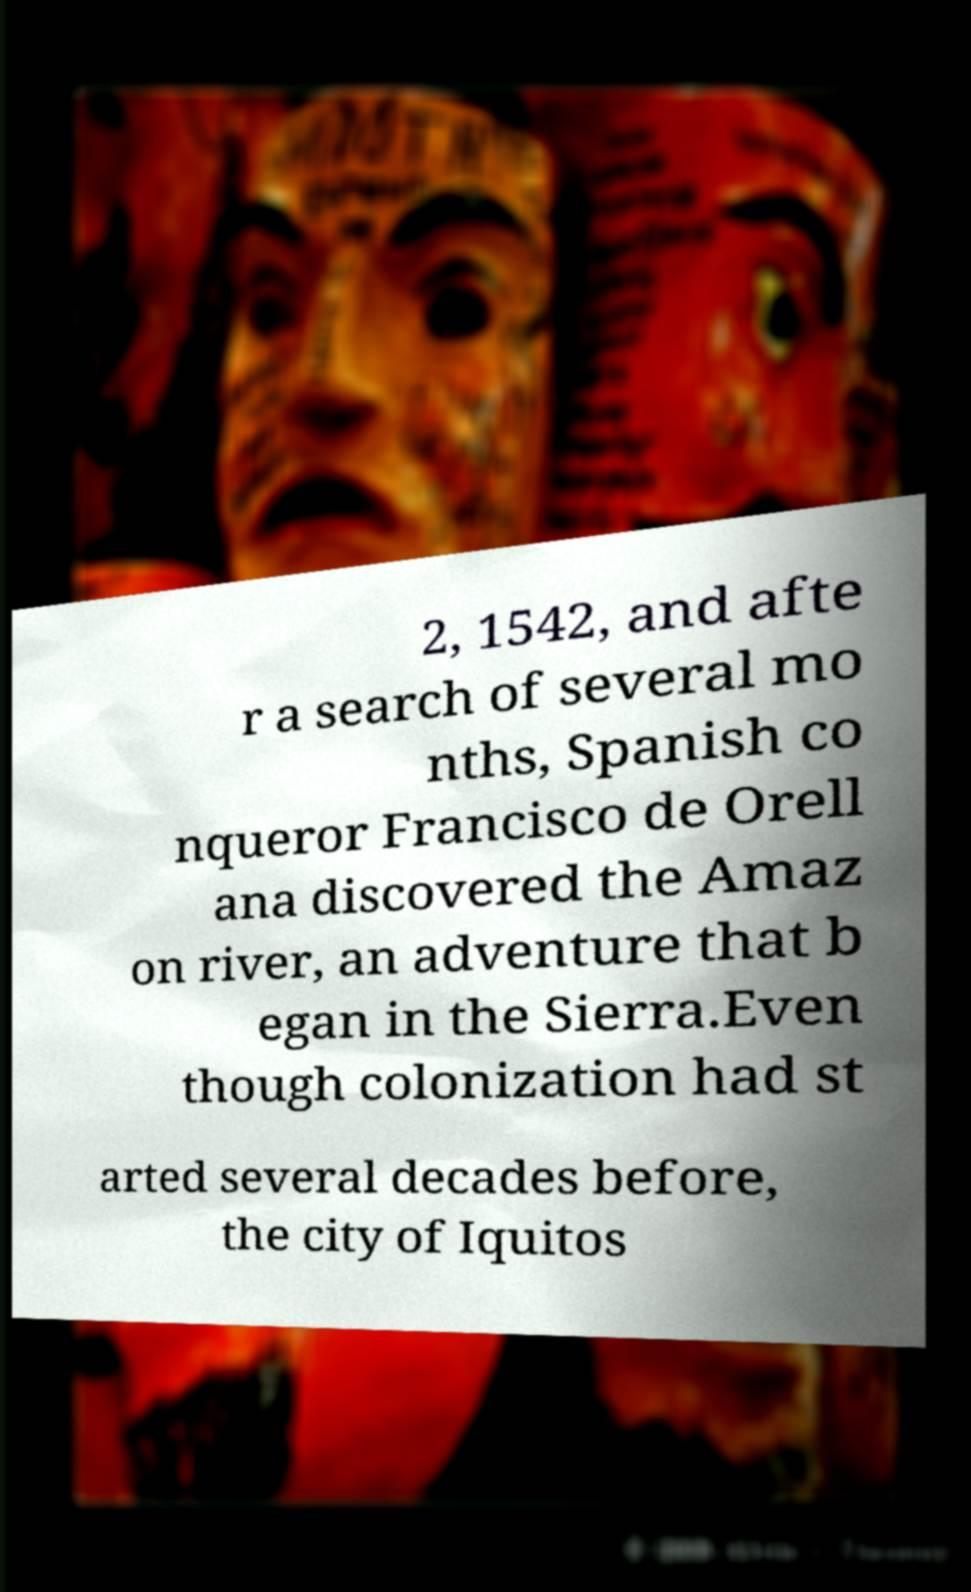Can you read and provide the text displayed in the image?This photo seems to have some interesting text. Can you extract and type it out for me? 2, 1542, and afte r a search of several mo nths, Spanish co nqueror Francisco de Orell ana discovered the Amaz on river, an adventure that b egan in the Sierra.Even though colonization had st arted several decades before, the city of Iquitos 